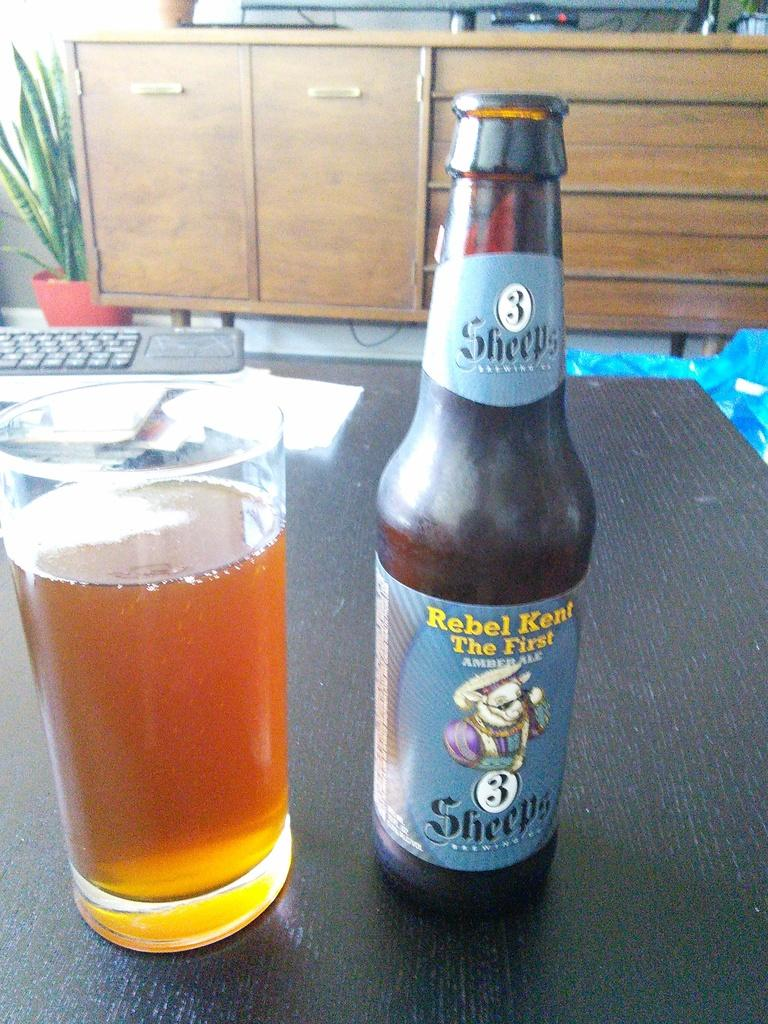<image>
Write a terse but informative summary of the picture. A bottle of Rebel Kent The First Amber Ale sitting next to a full glass on a table. 